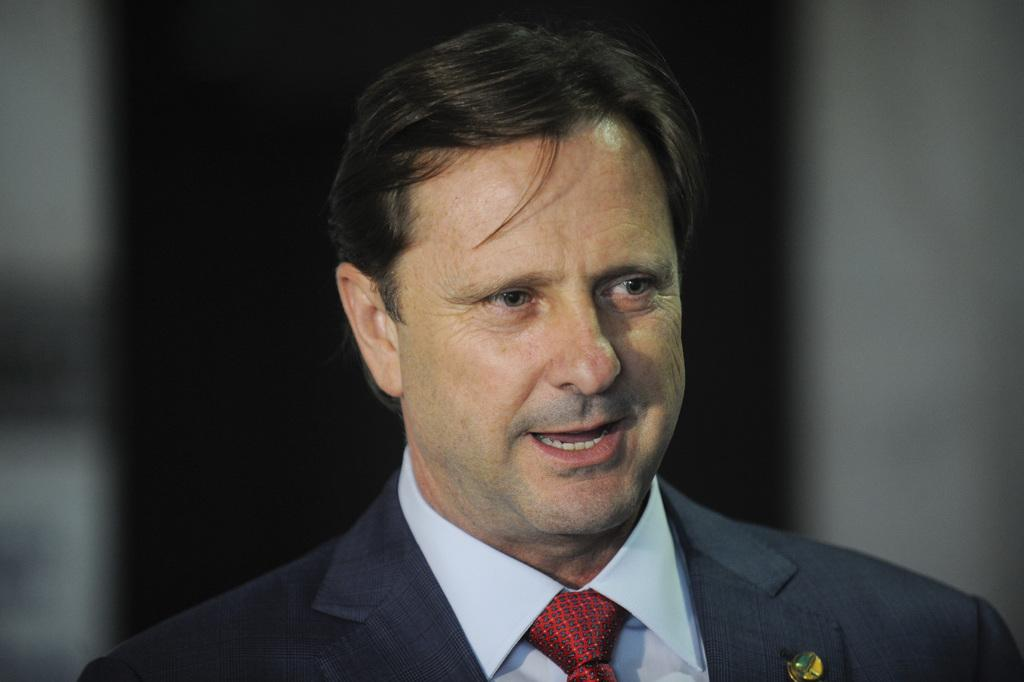What is present in the image? There is a person in the image. What is the person wearing? The person is wearing a shirt, a tie, and a blazer. Can you describe the background of the image? The background of the image is blurry. What type of loaf can be seen in the person's hand in the image? There is no loaf present in the image; the person is not holding anything. 